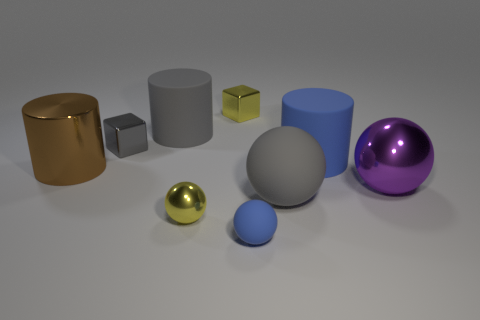There is a shiny cube right of the small gray thing to the left of the tiny metallic ball; are there any tiny blue things left of it?
Provide a succinct answer. No. What is the color of the large metal cylinder?
Ensure brevity in your answer.  Brown. There is a big metal object in front of the metallic cylinder; is its shape the same as the large blue thing?
Provide a succinct answer. No. What number of objects are either large blue cylinders or gray matte cylinders that are behind the brown metal cylinder?
Provide a short and direct response. 2. Is the material of the brown object that is in front of the tiny gray metallic object the same as the purple ball?
Your response must be concise. Yes. There is a yellow ball to the left of the yellow object behind the brown thing; what is it made of?
Your answer should be compact. Metal. Is the number of small yellow balls in front of the big metallic ball greater than the number of large blue matte objects that are on the left side of the large gray rubber cylinder?
Make the answer very short. Yes. The purple ball has what size?
Give a very brief answer. Large. Do the tiny metallic block that is behind the small gray metal object and the big shiny cylinder have the same color?
Your answer should be compact. No. Is there a big purple metal object that is on the right side of the small yellow object that is in front of the brown cylinder?
Give a very brief answer. Yes. 